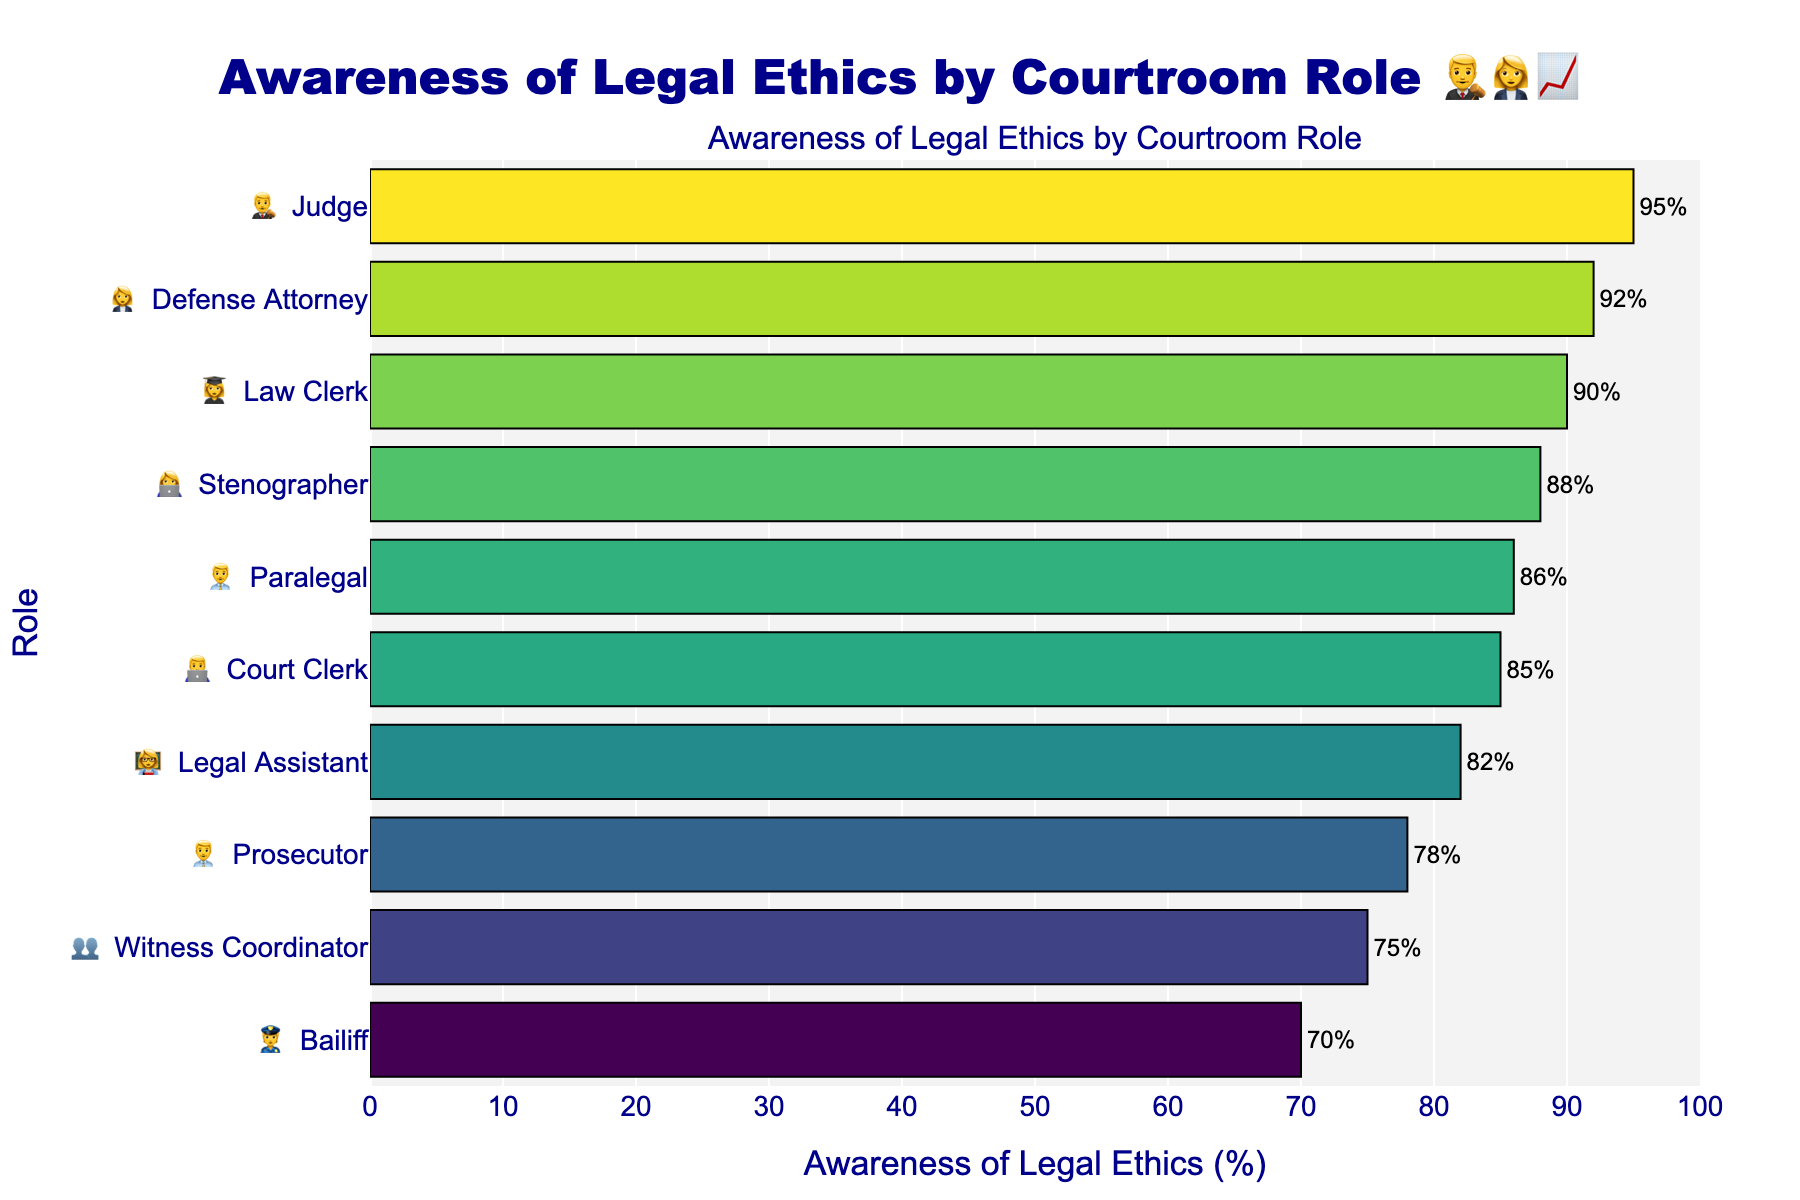What is the role with the highest awareness of legal ethics? By checking the bar with the longest length on the visualization, the highest awareness percentage is 95% for the "Judge".
Answer: Judge What is the average awareness of legal ethics across all roles? First, sum the awareness percentages for all roles (95 + 78 + 92 + 85 + 70 + 88 + 82 + 86 + 90 + 75 = 841). Then, divide by the number of roles (10), which gives an average of 841/10.
Answer: 84.1 Between prosecutors and defense attorneys, who has a higher awareness of legal ethics and by how much? The awareness percentages for the prosecutor and defense attorney are 78% and 92%, respectively. The difference is 92 - 78.
Answer: Defense attorneys by 14% Which role has the lowest awareness of legal ethics? By identifying the smallest bar in the visualization, the role with the lowest awareness is the "Bailiff" with 70%.
Answer: Bailiff What is the difference in awareness between the role with the highest and lowest percentages? The highest is 95% (Judge) and the lowest is 70% (Bailiff). Subtracting the lowest from the highest value, 95 - 70.
Answer: 25% How many roles have awareness of legal ethics above 80%? By visual inspection, the roles with awareness above 80% are Judge, Defense Attorney, Court Clerk, Stenographer, Legal Assistant, Paralegal, and Law Clerk, which total to 7 roles.
Answer: 7 What is the second lowest percentage of awareness of legal ethics? By viewing the bars from shortest to longest, the second shortest bar corresponds to the "Witness Coordinator" with 75%.
Answer: Witness Coordinator Compare the awareness of legal ethics between court clerks and legal assistants. Which is higher? The awareness percentage of court clerks is 85%, and that of legal assistants is 82%. Comparing the two values, court clerks have a higher awareness.
Answer: Court Clerk Which roles have an awareness between 80% and 90%? By reviewing the bars within the range of 80% to 90%, the corresponding roles are Court Clerk, Stenographer, Legal Assistant, Paralegal, and Law Clerk.
Answer: Court Clerk, Stenographer, Legal Assistant, Paralegal, Law Clerk 